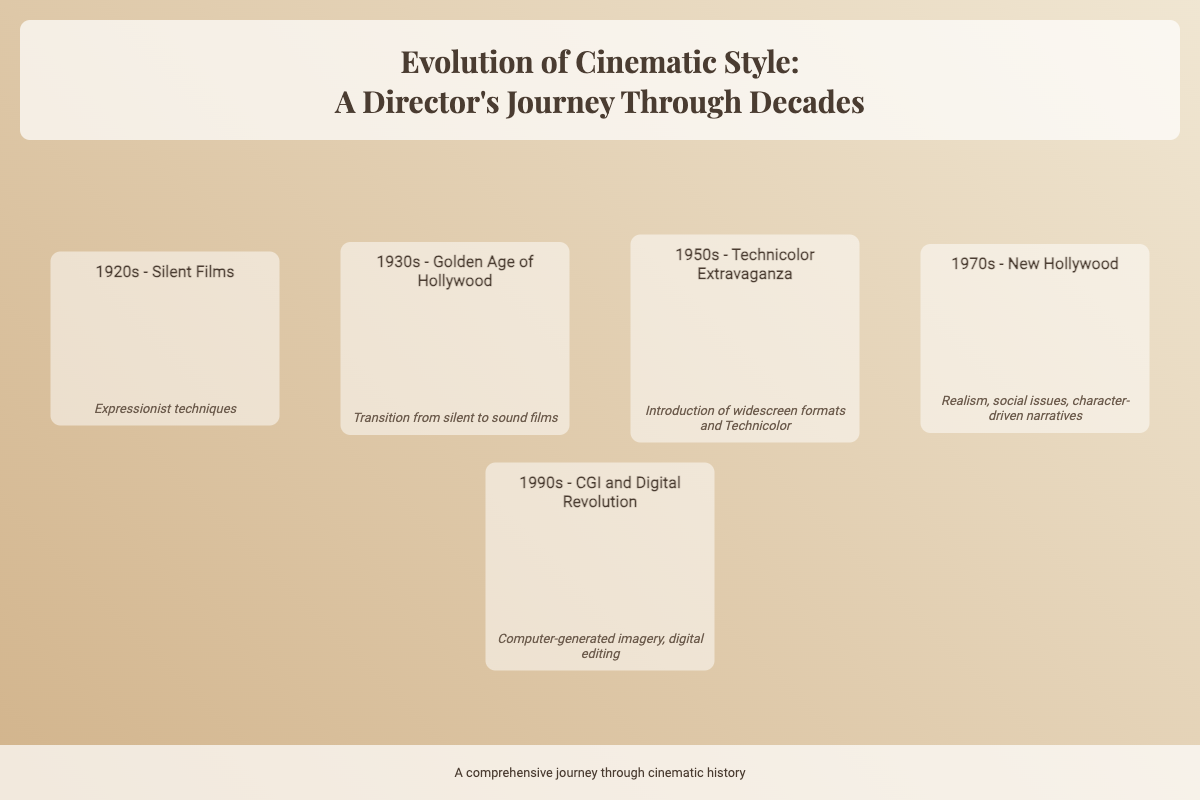What is the title of the book? The title is prominently displayed at the top of the document which reads "Evolution of Cinematic Style: A Director's Journey Through Decades."
Answer: Evolution of Cinematic Style: A Director's Journey Through Decades How many eras are presented on the cover? The timeline layout shows a total of five distinct eras.
Answer: 5 What key feature is associated with the 1970s era? The key feature for the 1970s era highlights realism, social issues, and character-driven narratives.
Answer: Realism, social issues, character-driven narratives Which decade introduced Technicolor? The 1950s era is noted for the introduction of widescreen formats and Technicolor.
Answer: 1950s What style is represented in the images of the document? The images are described as being sepia-toned, which gives a vintage aesthetic to the timeline.
Answer: Sepia-toned What is highlighted as a significant change in the 1930s? The transition from silent films to sound films is a significant change highlighted in that decade.
Answer: Transition from silent to sound films What design element is used for the era titles? The era titles are styled in bold font and are visually distinct, making them stand out.
Answer: Bold font What color scheme is used for the background? The background employs a gradient color scheme from a tan to a lighter beige.
Answer: Tan to lighter beige gradient 